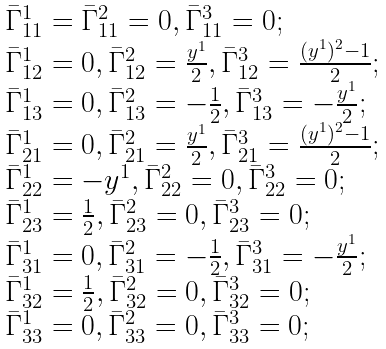Convert formula to latex. <formula><loc_0><loc_0><loc_500><loc_500>\begin{array} { l l l } \bar { \Gamma } ^ { 1 } _ { 1 1 } = \bar { \Gamma } ^ { 2 } _ { 1 1 } = 0 , \bar { \Gamma } ^ { 3 } _ { 1 1 } = 0 ; \\ \bar { \Gamma } ^ { 1 } _ { 1 2 } = 0 , \bar { \Gamma } ^ { 2 } _ { 1 2 } = \frac { y ^ { 1 } } { 2 } , \bar { \Gamma } ^ { 3 } _ { 1 2 } = \frac { ( y ^ { 1 } ) ^ { 2 } - 1 } { 2 } ; \\ \bar { \Gamma } ^ { 1 } _ { 1 3 } = 0 , \bar { \Gamma } ^ { 2 } _ { 1 3 } = - \frac { 1 } { 2 } , \bar { \Gamma } ^ { 3 } _ { 1 3 } = - \frac { y ^ { 1 } } { 2 } ; \\ \bar { \Gamma } ^ { 1 } _ { 2 1 } = 0 , \bar { \Gamma } ^ { 2 } _ { 2 1 } = \frac { y ^ { 1 } } { 2 } , \bar { \Gamma } ^ { 3 } _ { 2 1 } = \frac { ( y ^ { 1 } ) ^ { 2 } - 1 } { 2 } ; \\ \bar { \Gamma } ^ { 1 } _ { 2 2 } = - y ^ { 1 } , \bar { \Gamma } ^ { 2 } _ { 2 2 } = 0 , \bar { \Gamma } ^ { 3 } _ { 2 2 } = 0 ; \\ \bar { \Gamma } ^ { 1 } _ { 2 3 } = \frac { 1 } { 2 } , \bar { \Gamma } ^ { 2 } _ { 2 3 } = 0 , \bar { \Gamma } ^ { 3 } _ { 2 3 } = 0 ; \\ \bar { \Gamma } ^ { 1 } _ { 3 1 } = 0 , \bar { \Gamma } ^ { 2 } _ { 3 1 } = - \frac { 1 } { 2 } , \bar { \Gamma } ^ { 3 } _ { 3 1 } = - \frac { y ^ { 1 } } { 2 } ; \\ \bar { \Gamma } ^ { 1 } _ { 3 2 } = \frac { 1 } { 2 } , \bar { \Gamma } ^ { 2 } _ { 3 2 } = 0 , \bar { \Gamma } ^ { 3 } _ { 3 2 } = 0 ; \\ \bar { \Gamma } ^ { 1 } _ { 3 3 } = 0 , \bar { \Gamma } ^ { 2 } _ { 3 3 } = 0 , \bar { \Gamma } ^ { 3 } _ { 3 3 } = 0 ; \\ \end{array}</formula> 